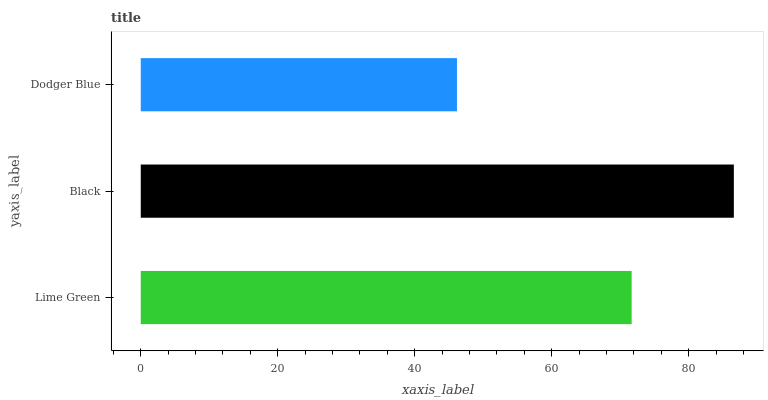Is Dodger Blue the minimum?
Answer yes or no. Yes. Is Black the maximum?
Answer yes or no. Yes. Is Black the minimum?
Answer yes or no. No. Is Dodger Blue the maximum?
Answer yes or no. No. Is Black greater than Dodger Blue?
Answer yes or no. Yes. Is Dodger Blue less than Black?
Answer yes or no. Yes. Is Dodger Blue greater than Black?
Answer yes or no. No. Is Black less than Dodger Blue?
Answer yes or no. No. Is Lime Green the high median?
Answer yes or no. Yes. Is Lime Green the low median?
Answer yes or no. Yes. Is Dodger Blue the high median?
Answer yes or no. No. Is Dodger Blue the low median?
Answer yes or no. No. 